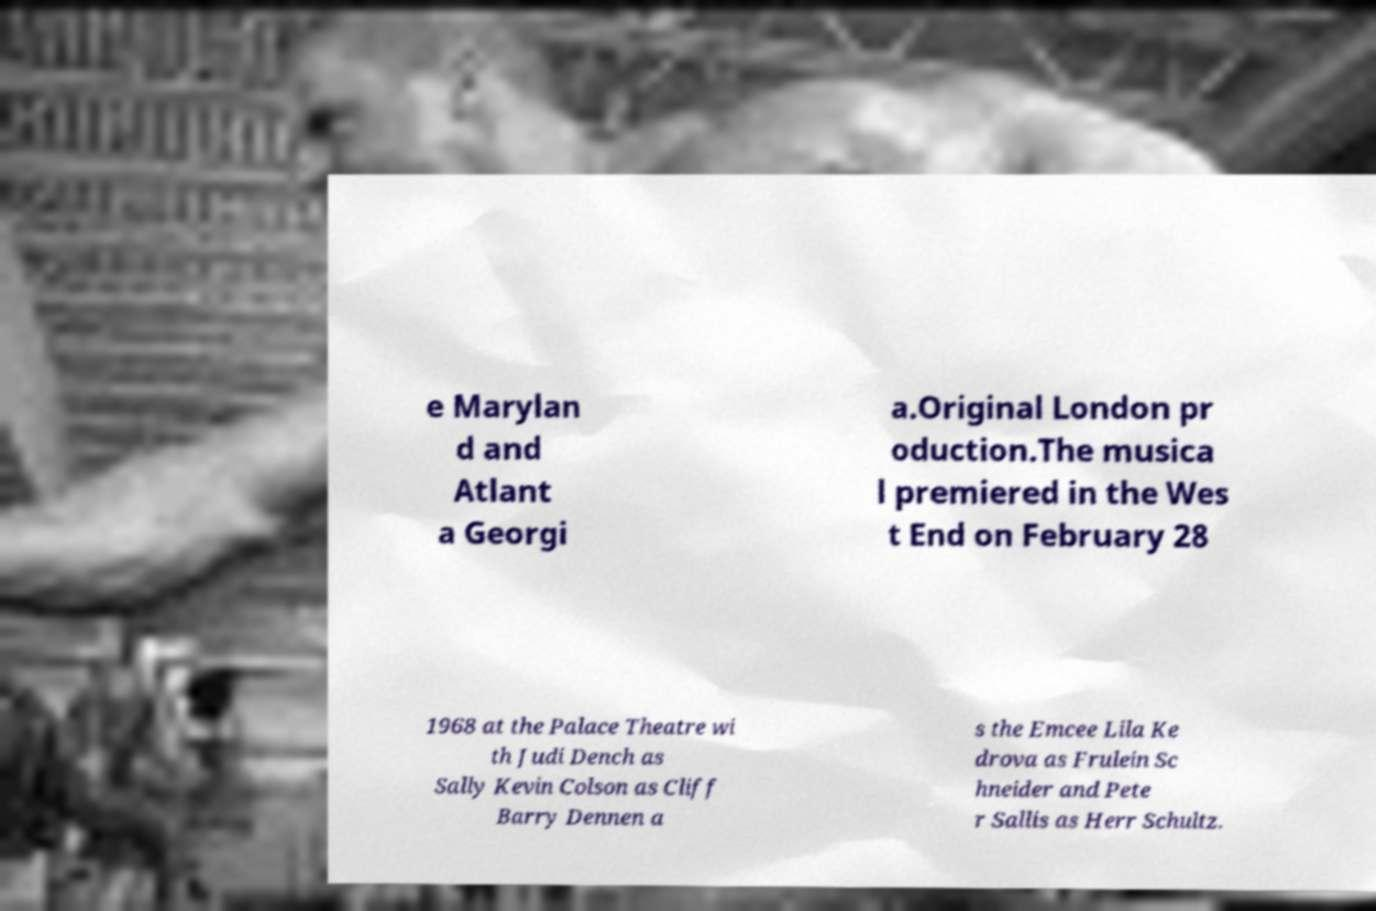What messages or text are displayed in this image? I need them in a readable, typed format. e Marylan d and Atlant a Georgi a.Original London pr oduction.The musica l premiered in the Wes t End on February 28 1968 at the Palace Theatre wi th Judi Dench as Sally Kevin Colson as Cliff Barry Dennen a s the Emcee Lila Ke drova as Frulein Sc hneider and Pete r Sallis as Herr Schultz. 